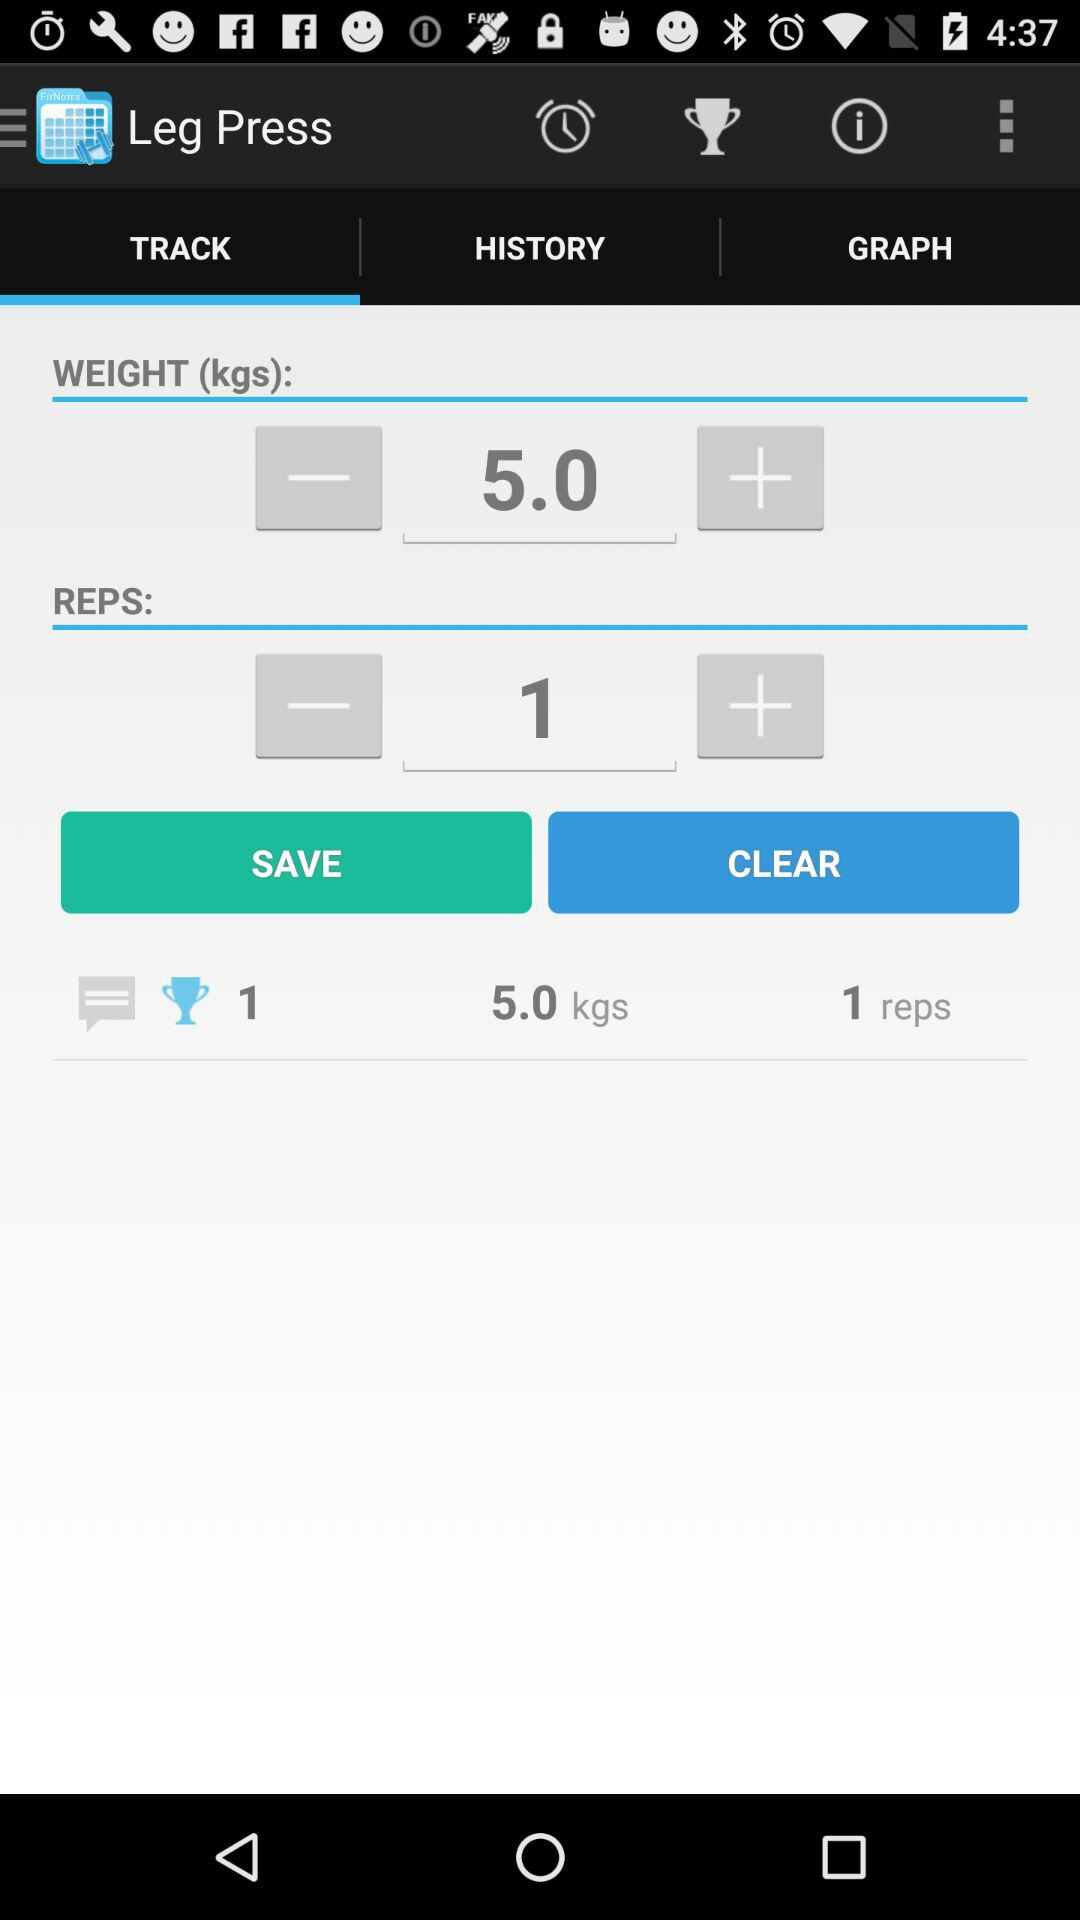What is the total weight lifted in kilograms?
Answer the question using a single word or phrase. 5.0 